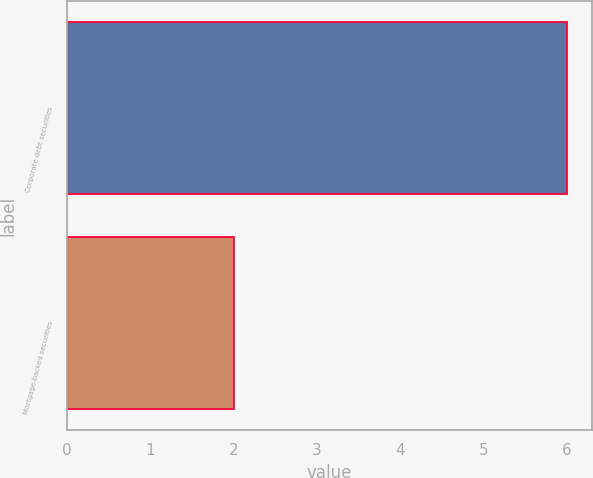Convert chart to OTSL. <chart><loc_0><loc_0><loc_500><loc_500><bar_chart><fcel>Corporate debt securities<fcel>Mortgage-backed securities<nl><fcel>6<fcel>2<nl></chart> 